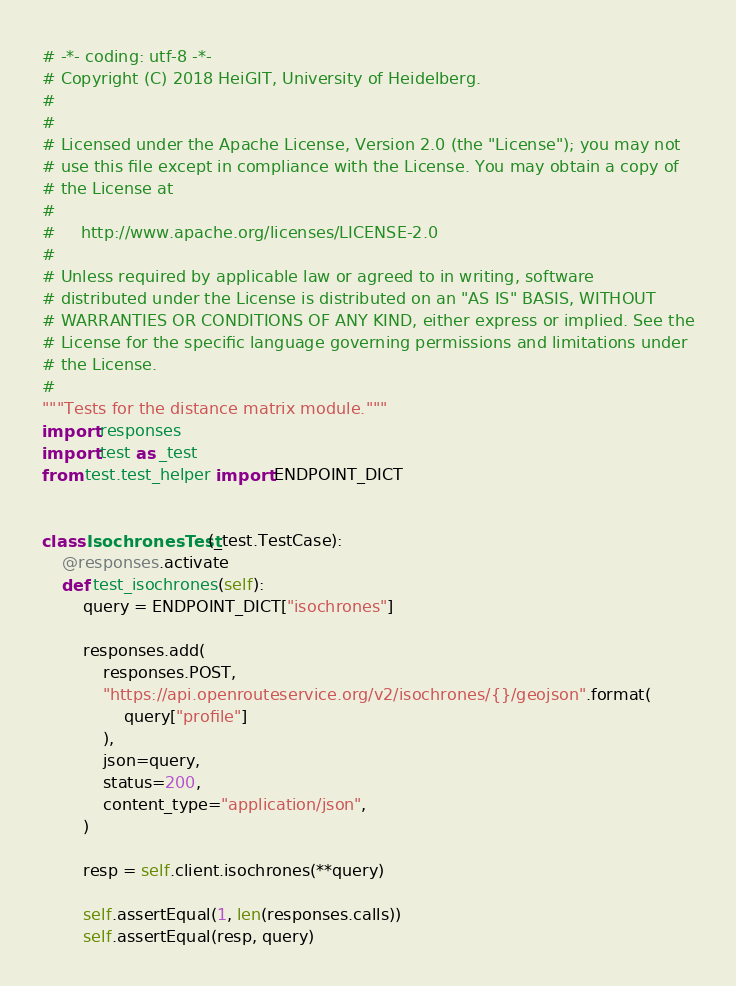<code> <loc_0><loc_0><loc_500><loc_500><_Python_># -*- coding: utf-8 -*-
# Copyright (C) 2018 HeiGIT, University of Heidelberg.
#
#
# Licensed under the Apache License, Version 2.0 (the "License"); you may not
# use this file except in compliance with the License. You may obtain a copy of
# the License at
#
#     http://www.apache.org/licenses/LICENSE-2.0
#
# Unless required by applicable law or agreed to in writing, software
# distributed under the License is distributed on an "AS IS" BASIS, WITHOUT
# WARRANTIES OR CONDITIONS OF ANY KIND, either express or implied. See the
# License for the specific language governing permissions and limitations under
# the License.
#
"""Tests for the distance matrix module."""
import responses
import test as _test
from test.test_helper import ENDPOINT_DICT


class IsochronesTest(_test.TestCase):
    @responses.activate
    def test_isochrones(self):
        query = ENDPOINT_DICT["isochrones"]

        responses.add(
            responses.POST,
            "https://api.openrouteservice.org/v2/isochrones/{}/geojson".format(
                query["profile"]
            ),
            json=query,
            status=200,
            content_type="application/json",
        )

        resp = self.client.isochrones(**query)

        self.assertEqual(1, len(responses.calls))
        self.assertEqual(resp, query)
</code> 